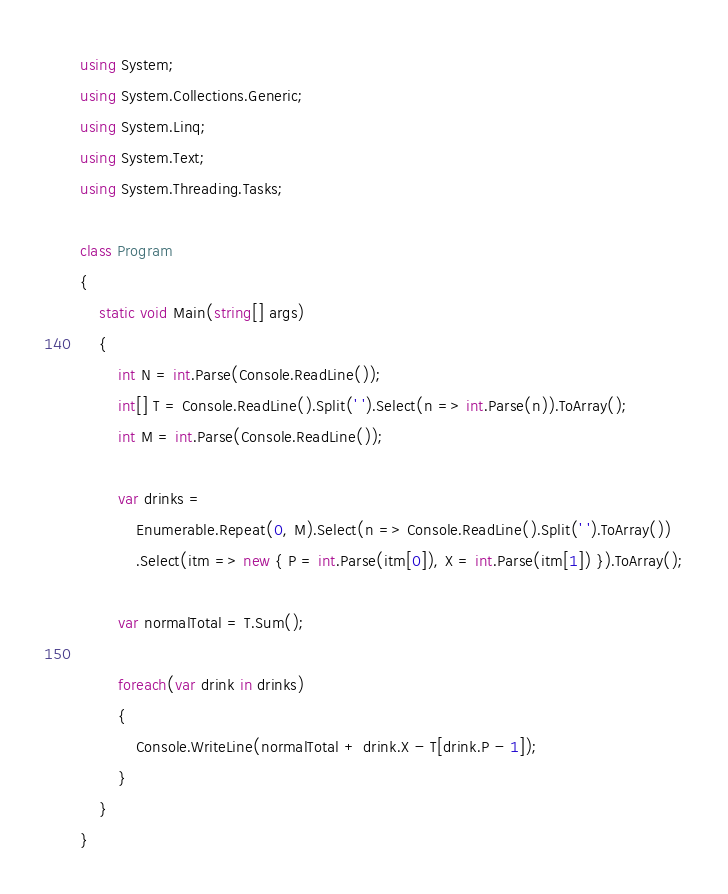Convert code to text. <code><loc_0><loc_0><loc_500><loc_500><_C#_>using System;
using System.Collections.Generic;
using System.Linq;
using System.Text;
using System.Threading.Tasks;

class Program
{
    static void Main(string[] args)
    {
        int N = int.Parse(Console.ReadLine());
        int[] T = Console.ReadLine().Split(' ').Select(n => int.Parse(n)).ToArray();
        int M = int.Parse(Console.ReadLine());

        var drinks = 
            Enumerable.Repeat(0, M).Select(n => Console.ReadLine().Split(' ').ToArray())
            .Select(itm => new { P = int.Parse(itm[0]), X = int.Parse(itm[1]) }).ToArray();

        var normalTotal = T.Sum();

        foreach(var drink in drinks)
        {
            Console.WriteLine(normalTotal + drink.X - T[drink.P - 1]);
        }
    }
}</code> 